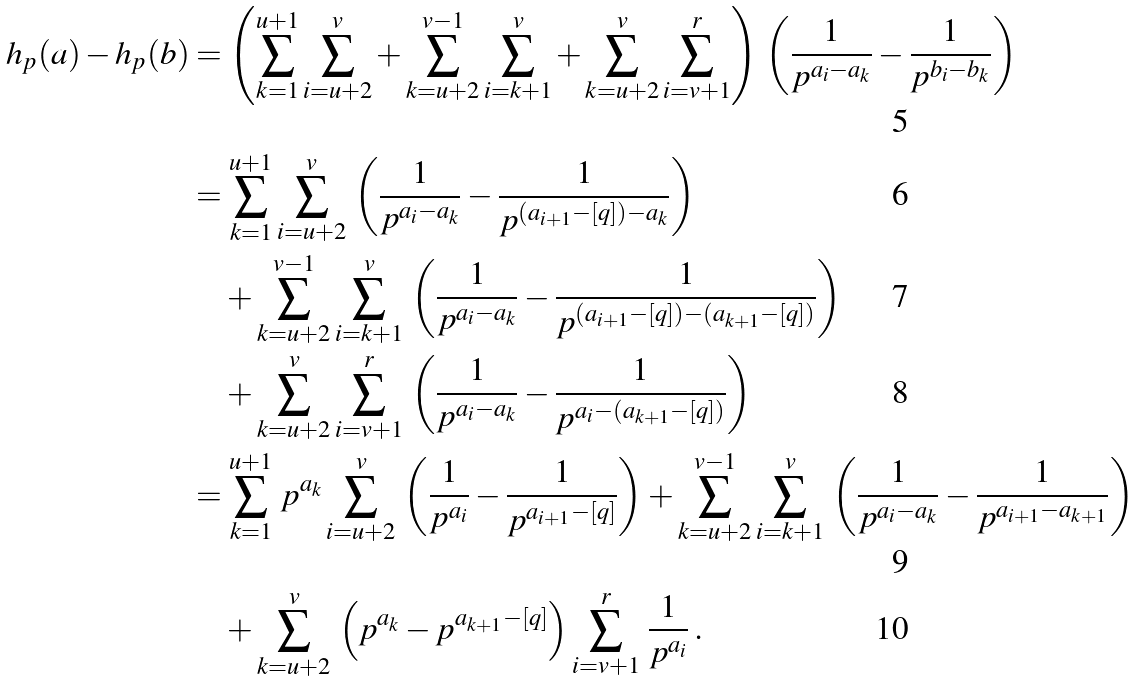Convert formula to latex. <formula><loc_0><loc_0><loc_500><loc_500>h _ { p } ( a ) - h _ { p } ( b ) & = \left ( \sum _ { k = 1 } ^ { u + 1 } \sum _ { i = u + 2 } ^ { v } + \sum _ { k = u + 2 } ^ { v - 1 } \sum _ { i = k + 1 } ^ { v } + \sum _ { k = u + 2 } ^ { v } \sum _ { i = v + 1 } ^ { r } \right ) \, \left ( \frac { 1 } { p ^ { a _ { i } - a _ { k } } } - \frac { 1 } { p ^ { b _ { i } - b _ { k } } } \right ) \\ & = \sum _ { k = 1 } ^ { u + 1 } \sum _ { i = u + 2 } ^ { v } \, \left ( \frac { 1 } { p ^ { a _ { i } - a _ { k } } } - \frac { 1 } { p ^ { ( a _ { i + 1 } - [ q ] ) - a _ { k } } } \right ) \\ & \quad + \sum _ { k = u + 2 } ^ { v - 1 } \sum _ { i = k + 1 } ^ { v } \, \left ( \frac { 1 } { p ^ { a _ { i } - a _ { k } } } - \frac { 1 } { p ^ { ( a _ { i + 1 } - [ q ] ) - ( a _ { k + 1 } - [ q ] ) } } \right ) \\ & \quad + \sum _ { k = u + 2 } ^ { v } \sum _ { i = v + 1 } ^ { r } \, \left ( \frac { 1 } { p ^ { a _ { i } - a _ { k } } } - \frac { 1 } { p ^ { a _ { i } - ( a _ { k + 1 } - [ q ] ) } } \right ) \\ & = \sum _ { k = 1 } ^ { u + 1 } \, p ^ { a _ { k } } \sum _ { i = u + 2 } ^ { v } \, \left ( \frac { 1 } { p ^ { a _ { i } } } - \frac { 1 } { p ^ { a _ { i + 1 } - [ q ] } } \right ) + \sum _ { k = u + 2 } ^ { v - 1 } \sum _ { i = k + 1 } ^ { v } \, \left ( \frac { 1 } { p ^ { a _ { i } - a _ { k } } } - \frac { 1 } { p ^ { a _ { i + 1 } - a _ { k + 1 } } } \right ) \\ & \quad + \sum _ { k = u + 2 } ^ { v } \, \left ( p ^ { a _ { k } } - p ^ { a _ { k + 1 } - [ q ] } \right ) \sum _ { i = v + 1 } ^ { r } \, \frac { 1 } { p ^ { a _ { i } } } \, .</formula> 